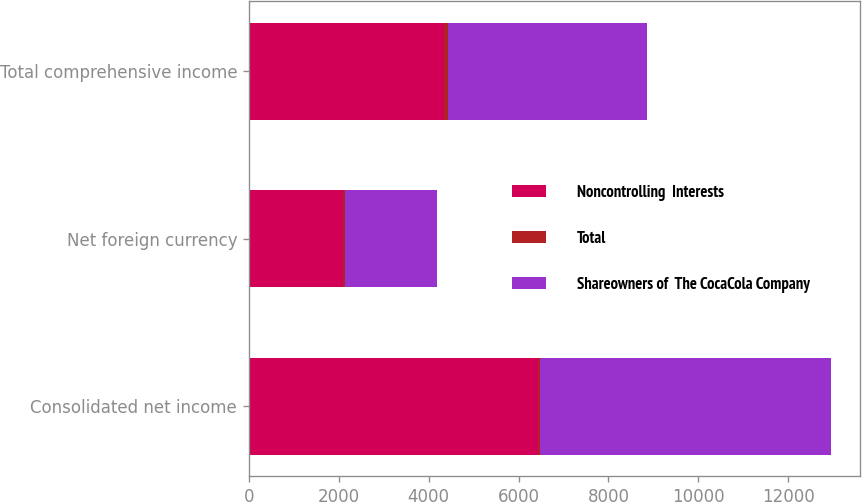Convert chart to OTSL. <chart><loc_0><loc_0><loc_500><loc_500><stacked_bar_chart><ecel><fcel>Consolidated net income<fcel>Net foreign currency<fcel>Total comprehensive income<nl><fcel>Noncontrolling  Interests<fcel>6434<fcel>2088<fcel>4334<nl><fcel>Total<fcel>42<fcel>53<fcel>95<nl><fcel>Shareowners of  The CocaCola Company<fcel>6476<fcel>2035<fcel>4429<nl></chart> 